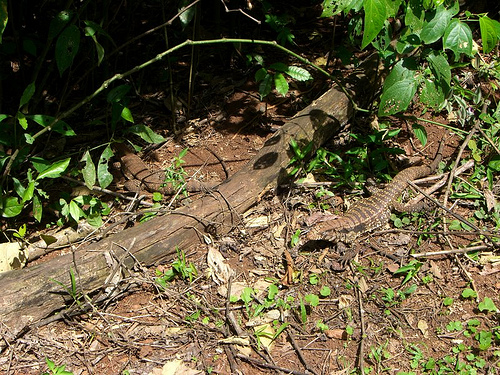<image>
Can you confirm if the leaf is in front of the sand? Yes. The leaf is positioned in front of the sand, appearing closer to the camera viewpoint. Where is the lizard in relation to the ground? Is it in front of the ground? No. The lizard is not in front of the ground. The spatial positioning shows a different relationship between these objects. 